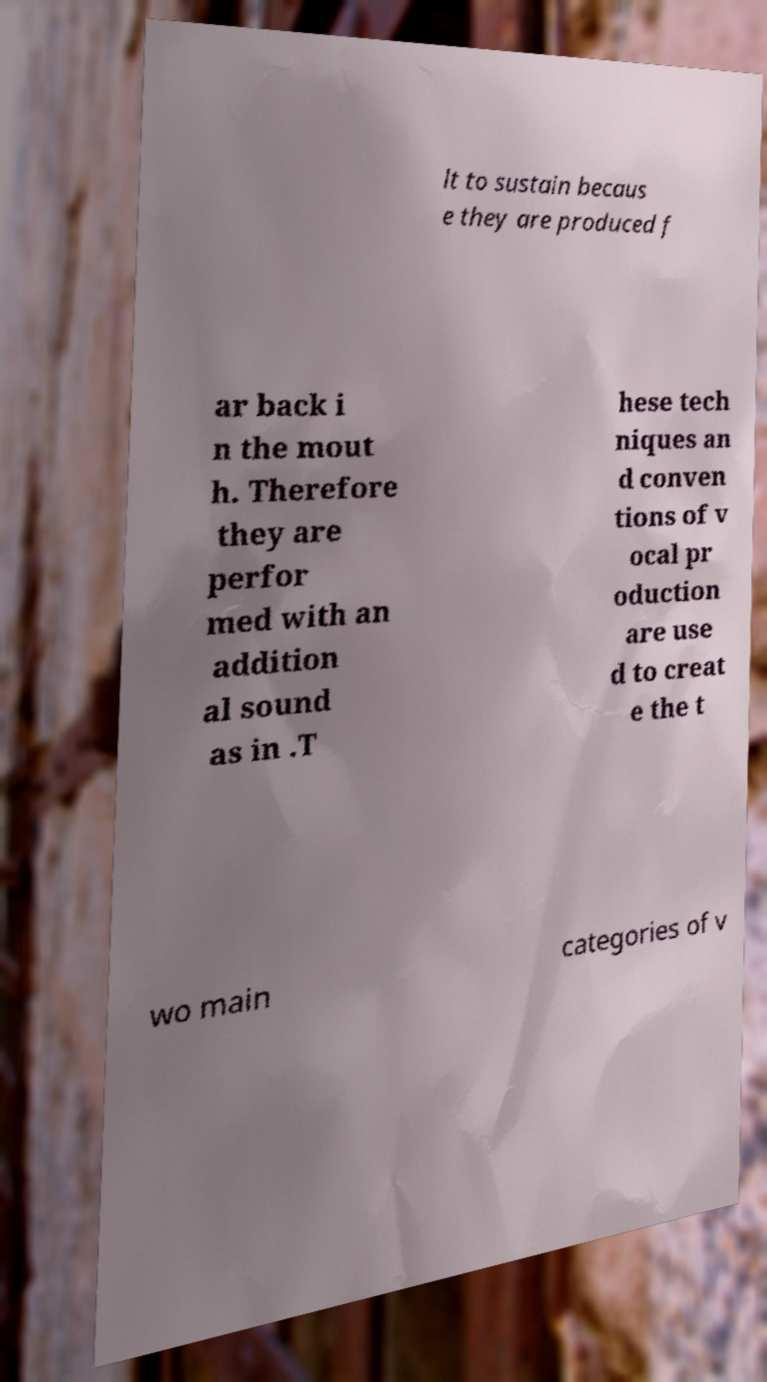Can you accurately transcribe the text from the provided image for me? lt to sustain becaus e they are produced f ar back i n the mout h. Therefore they are perfor med with an addition al sound as in .T hese tech niques an d conven tions of v ocal pr oduction are use d to creat e the t wo main categories of v 